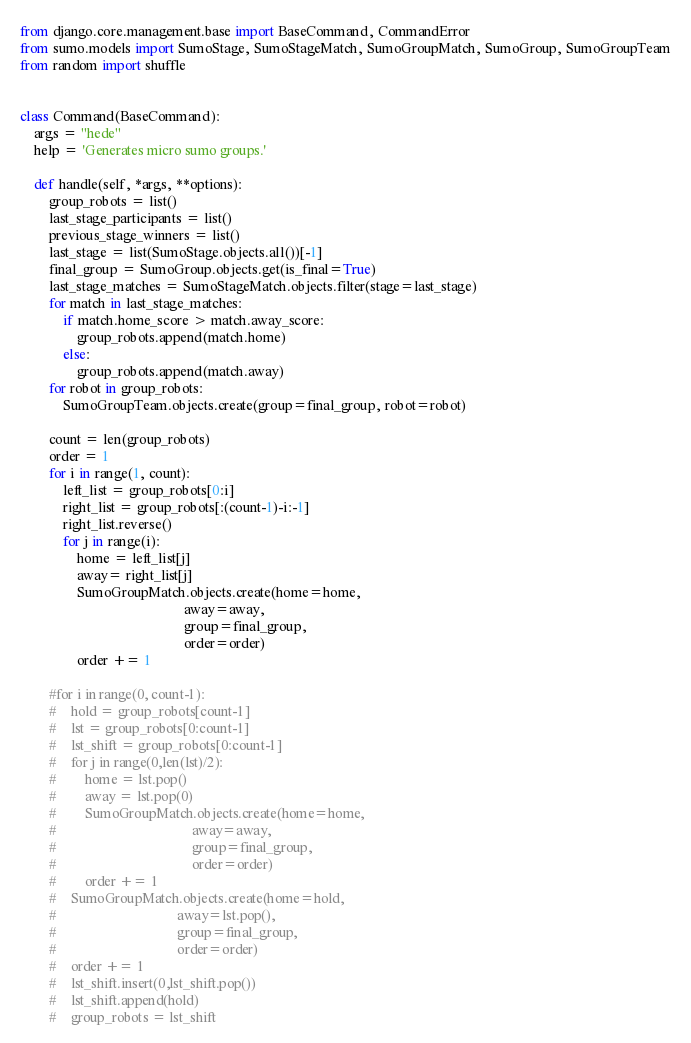Convert code to text. <code><loc_0><loc_0><loc_500><loc_500><_Python_>from django.core.management.base import BaseCommand, CommandError
from sumo.models import SumoStage, SumoStageMatch, SumoGroupMatch, SumoGroup, SumoGroupTeam
from random import shuffle


class Command(BaseCommand):
    args = "hede"
    help = 'Generates micro sumo groups.'

    def handle(self, *args, **options):
        group_robots = list()
        last_stage_participants = list()
        previous_stage_winners = list()
        last_stage = list(SumoStage.objects.all())[-1]
        final_group = SumoGroup.objects.get(is_final=True)
        last_stage_matches = SumoStageMatch.objects.filter(stage=last_stage)
        for match in last_stage_matches:
            if match.home_score > match.away_score:
                group_robots.append(match.home)
            else:
                group_robots.append(match.away)
        for robot in group_robots:
            SumoGroupTeam.objects.create(group=final_group, robot=robot)

        count = len(group_robots)
        order = 1
        for i in range(1, count):
            left_list = group_robots[0:i]
            right_list = group_robots[:(count-1)-i:-1]
            right_list.reverse()
            for j in range(i):
                home = left_list[j]
                away= right_list[j]
                SumoGroupMatch.objects.create(home=home,
                                              away=away,
                                              group=final_group,
                                              order=order)
                order += 1

        #for i in range(0, count-1):
        #    hold = group_robots[count-1]
        #    lst = group_robots[0:count-1]
        #    lst_shift = group_robots[0:count-1]
        #    for j in range(0,len(lst)/2):
        #        home = lst.pop()
        #        away = lst.pop(0)
        #        SumoGroupMatch.objects.create(home=home,
        #                                      away=away,
        #                                      group=final_group,
        #                                      order=order)
        #        order += 1
        #    SumoGroupMatch.objects.create(home=hold,
        #                                  away=lst.pop(),
        #                                  group=final_group,
        #                                  order=order)
        #    order += 1
        #    lst_shift.insert(0,lst_shift.pop())
        #    lst_shift.append(hold)
        #    group_robots = lst_shift
</code> 